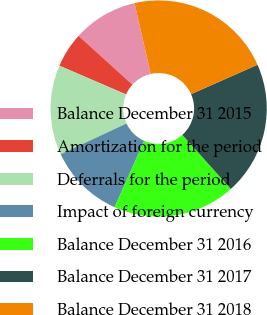Convert chart to OTSL. <chart><loc_0><loc_0><loc_500><loc_500><pie_chart><fcel>Balance December 31 2015<fcel>Amortization for the period<fcel>Deferrals for the period<fcel>Impact of foreign currency<fcel>Balance December 31 2016<fcel>Balance December 31 2017<fcel>Balance December 31 2018<nl><fcel>9.69%<fcel>5.25%<fcel>13.43%<fcel>11.36%<fcel>18.32%<fcel>19.99%<fcel>21.96%<nl></chart> 